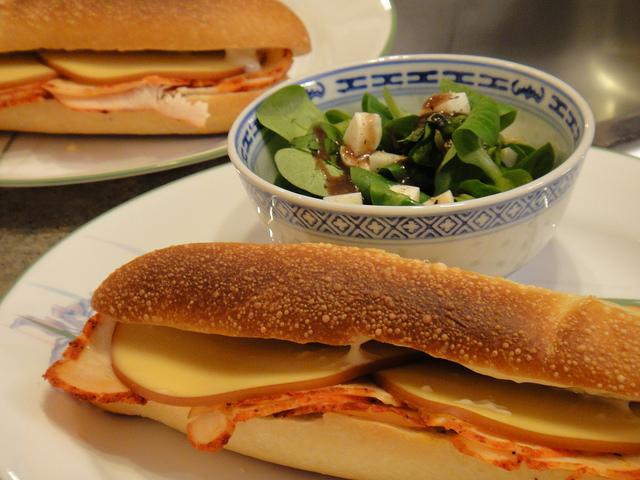Does the sandwich have meat?
Keep it brief. Yes. How many sandwiches do you see?
Short answer required. 2. Is there a drink?
Give a very brief answer. No. What is the green stuff?
Quick response, please. Salad. What kind of salad is that?
Short answer required. Spinach. What is holding the sandwich together?
Answer briefly. Bread. Are there two servings of French fries on the table?
Answer briefly. No. 